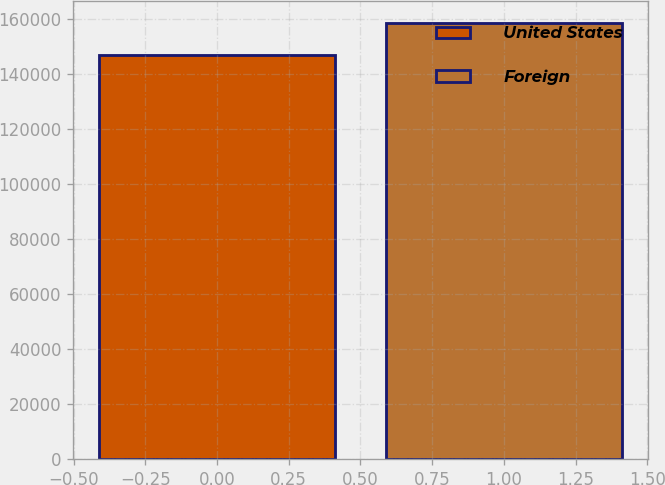<chart> <loc_0><loc_0><loc_500><loc_500><bar_chart><fcel>United States<fcel>Foreign<nl><fcel>146940<fcel>158506<nl></chart> 